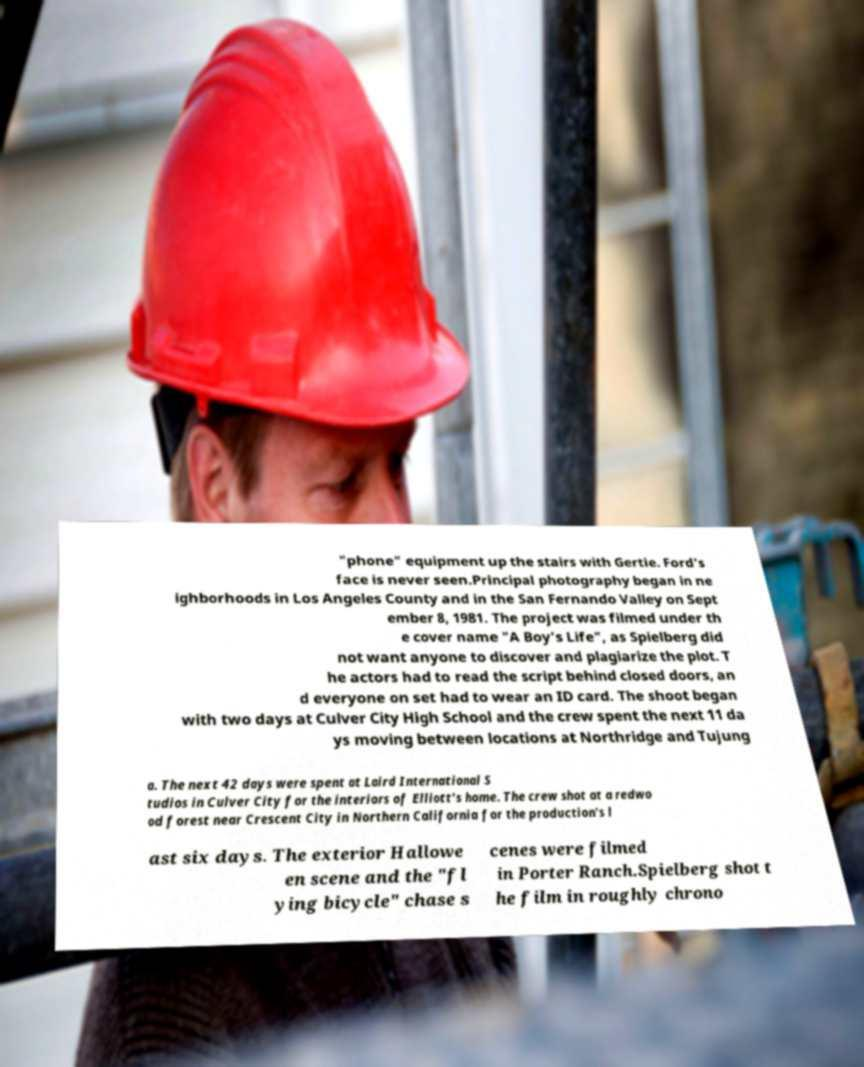For documentation purposes, I need the text within this image transcribed. Could you provide that? "phone" equipment up the stairs with Gertie. Ford's face is never seen.Principal photography began in ne ighborhoods in Los Angeles County and in the San Fernando Valley on Sept ember 8, 1981. The project was filmed under th e cover name "A Boy's Life", as Spielberg did not want anyone to discover and plagiarize the plot. T he actors had to read the script behind closed doors, an d everyone on set had to wear an ID card. The shoot began with two days at Culver City High School and the crew spent the next 11 da ys moving between locations at Northridge and Tujung a. The next 42 days were spent at Laird International S tudios in Culver City for the interiors of Elliott's home. The crew shot at a redwo od forest near Crescent City in Northern California for the production's l ast six days. The exterior Hallowe en scene and the "fl ying bicycle" chase s cenes were filmed in Porter Ranch.Spielberg shot t he film in roughly chrono 